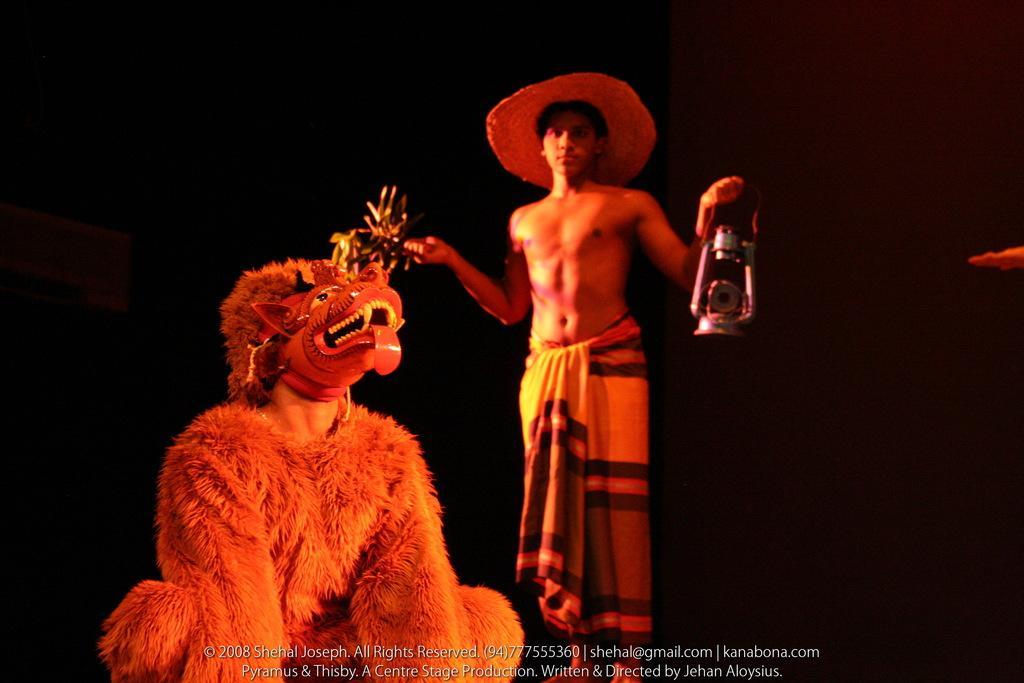Can you describe this image briefly? In the foreground of the image we can see a person wearing different costumes and mask is in the squat position, we can see this person wearing hat on his head and a cloth is holding a lantern in his hand is standing here. The background of the image is dark. Here we can see the watermark on the bottom of the image. 